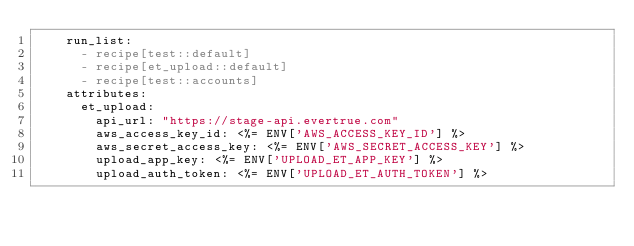<code> <loc_0><loc_0><loc_500><loc_500><_YAML_>    run_list:
      - recipe[test::default]
      - recipe[et_upload::default]
      - recipe[test::accounts]
    attributes:
      et_upload:
        api_url: "https://stage-api.evertrue.com"
        aws_access_key_id: <%= ENV['AWS_ACCESS_KEY_ID'] %>
        aws_secret_access_key: <%= ENV['AWS_SECRET_ACCESS_KEY'] %>
        upload_app_key: <%= ENV['UPLOAD_ET_APP_KEY'] %>
        upload_auth_token: <%= ENV['UPLOAD_ET_AUTH_TOKEN'] %>
</code> 